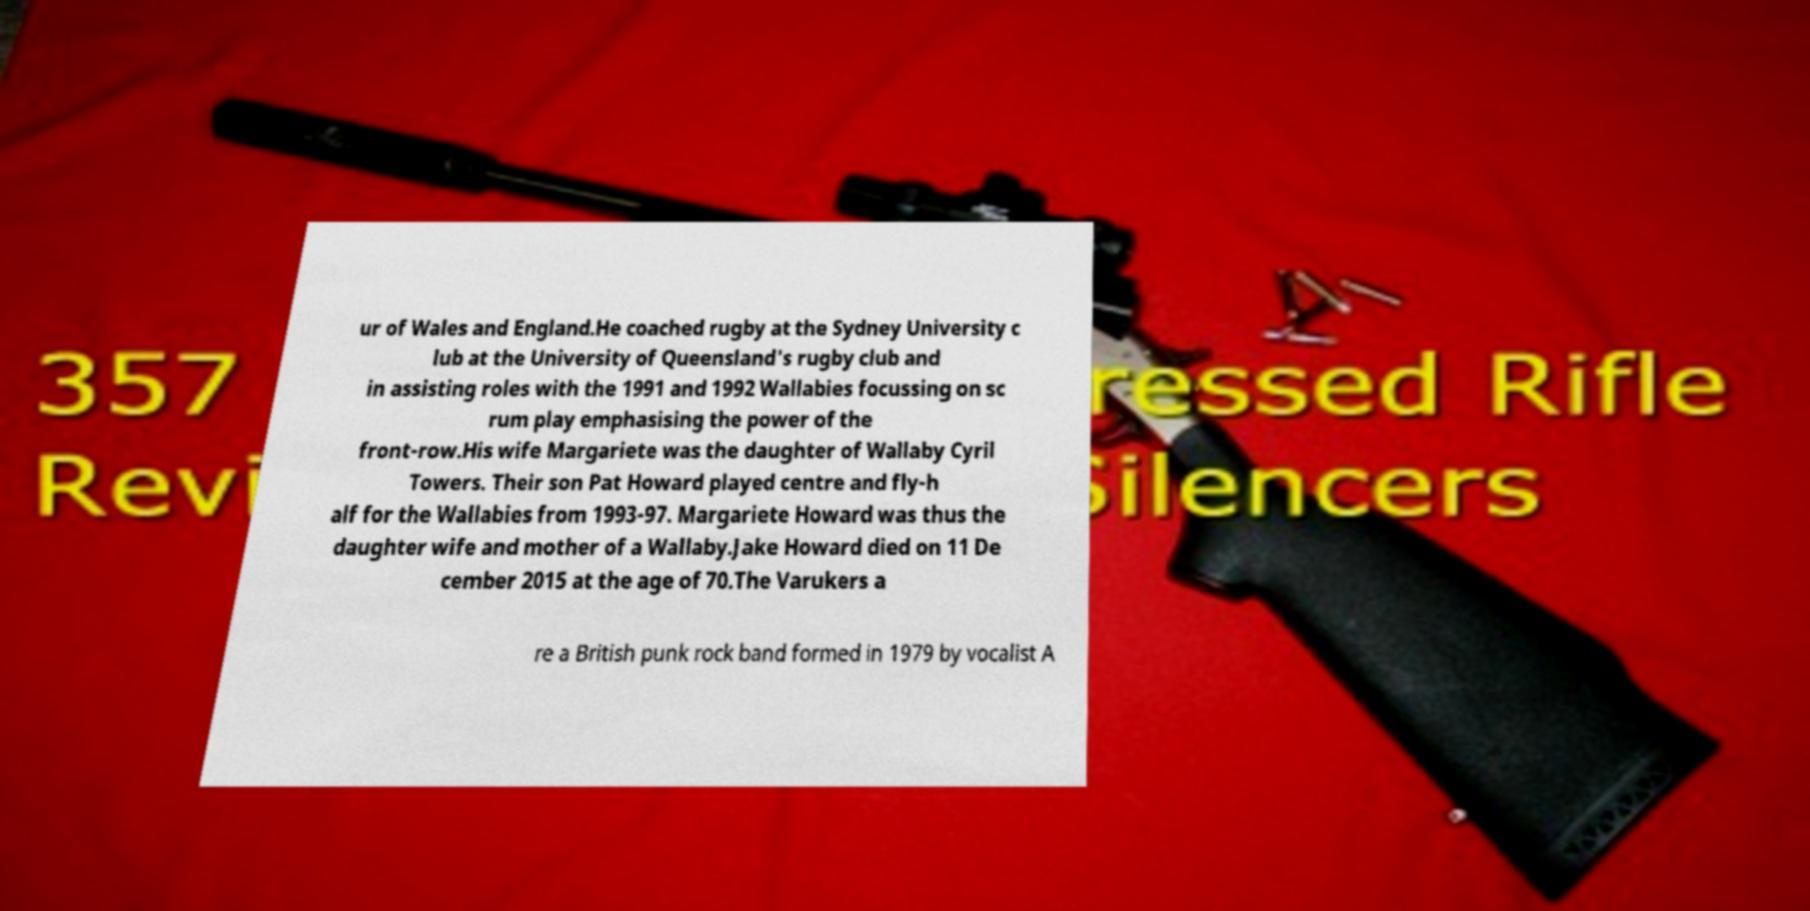I need the written content from this picture converted into text. Can you do that? ur of Wales and England.He coached rugby at the Sydney University c lub at the University of Queensland's rugby club and in assisting roles with the 1991 and 1992 Wallabies focussing on sc rum play emphasising the power of the front-row.His wife Margariete was the daughter of Wallaby Cyril Towers. Their son Pat Howard played centre and fly-h alf for the Wallabies from 1993-97. Margariete Howard was thus the daughter wife and mother of a Wallaby.Jake Howard died on 11 De cember 2015 at the age of 70.The Varukers a re a British punk rock band formed in 1979 by vocalist A 